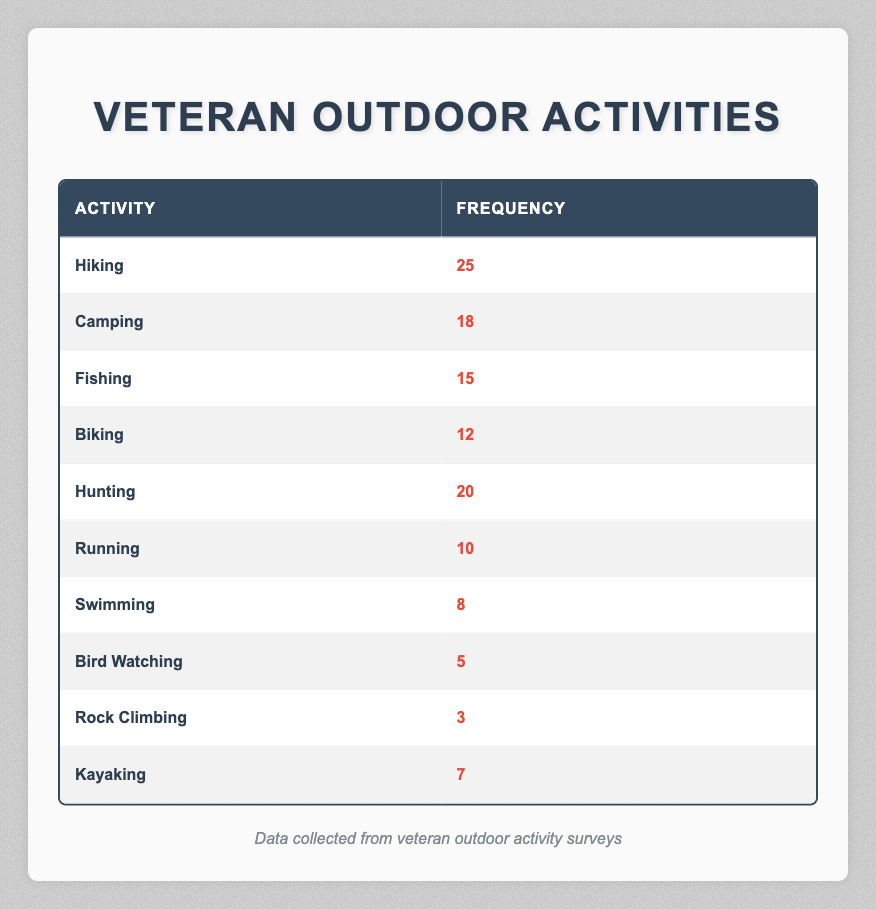What is the frequency of the most participated outdoor activity by veterans? The table shows that the activity with the highest frequency is Hiking, which has a value of 25.
Answer: 25 How many veterans participated in Camping and Fishing combined? The frequency for Camping is 18 and for Fishing is 15. When combined, the total frequency is 18 + 15 = 33.
Answer: 33 Is the frequency of Swimming greater than that of Bird Watching? The frequency of Swimming is 8 and of Bird Watching is 5. Since 8 is greater than 5, the statement is true.
Answer: Yes What is the average frequency of the top three activities? The top three activities are Hiking (25), Hunting (20), and Camping (18). Their sum is 25 + 20 + 18 = 63. Dividing by 3 gives an average of 63 / 3 = 21.
Answer: 21 Which activity has the least frequency, and what is that frequency? The activity with the lowest frequency is Rock Climbing, which has a frequency of 3.
Answer: Rock Climbing; 3 What is the difference in frequency between Hiking and Biking? The frequency of Hiking is 25 and the frequency of Biking is 12. The difference is calculated as 25 - 12 = 13.
Answer: 13 Are there more veterans who enjoy Biking than those who enjoy Kayaking? The frequency for Biking is 12 and for Kayaking is 7. Since 12 is greater than 7, the answer is yes.
Answer: Yes What activities fall within the frequency range of 10 to 20? From the table, the activities that fall within this range are Fishing (15), Biking (12), and Hunting (20). This includes a total of three activities.
Answer: 3 How many activities have a frequency less than 10? According to the table, Swimming (8), Bird Watching (5), Rock Climbing (3), and Kayaking (7) have frequencies less than 10. This sums up to four activities.
Answer: 4 